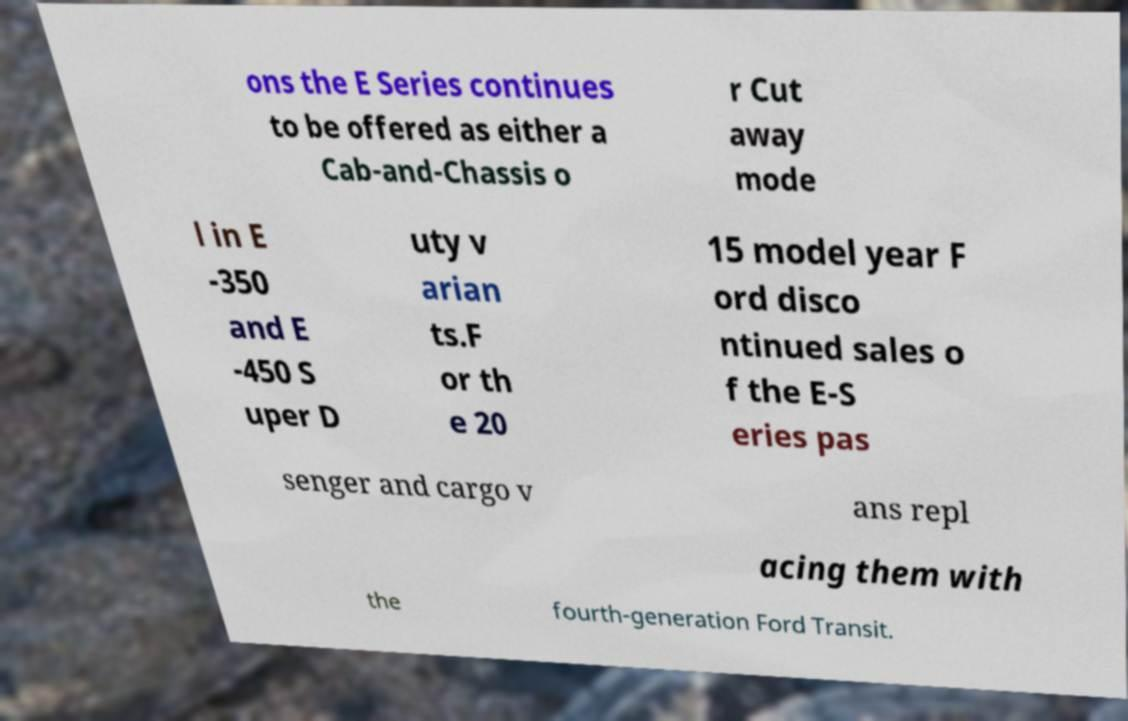Can you read and provide the text displayed in the image?This photo seems to have some interesting text. Can you extract and type it out for me? ons the E Series continues to be offered as either a Cab-and-Chassis o r Cut away mode l in E -350 and E -450 S uper D uty v arian ts.F or th e 20 15 model year F ord disco ntinued sales o f the E-S eries pas senger and cargo v ans repl acing them with the fourth-generation Ford Transit. 